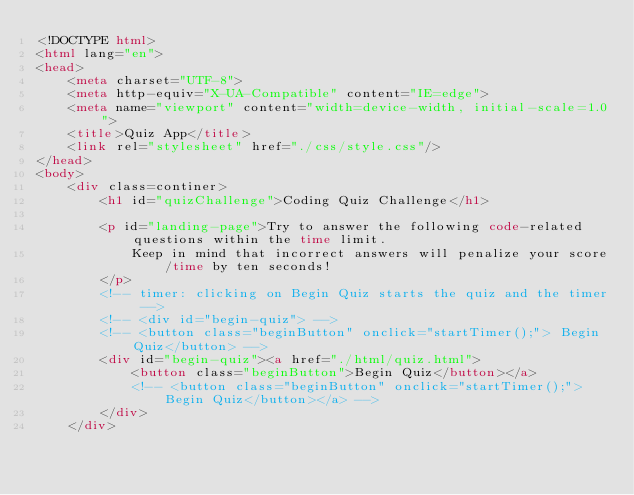Convert code to text. <code><loc_0><loc_0><loc_500><loc_500><_HTML_><!DOCTYPE html>
<html lang="en">
<head>
    <meta charset="UTF-8">
    <meta http-equiv="X-UA-Compatible" content="IE=edge">
    <meta name="viewport" content="width=device-width, initial-scale=1.0">
    <title>Quiz App</title>
    <link rel="stylesheet" href="./css/style.css"/>
</head>
<body>
    <div class=continer>
        <h1 id="quizChallenge">Coding Quiz Challenge</h1>
        
        <p id="landing-page">Try to answer the following code-related questions within the time limit.
            Keep in mind that incorrect answers will penalize your score/time by ten seconds!
        </p>
        <!-- timer: clicking on Begin Quiz starts the quiz and the timer -->
        <!-- <div id="begin-quiz"> -->
        <!-- <button class="beginButton" onclick="startTimer();"> Begin Quiz</button> -->
        <div id="begin-quiz"><a href="./html/quiz.html">
            <button class="beginButton">Begin Quiz</button></a>
            <!-- <button class="beginButton" onclick="startTimer();">Begin Quiz</button></a> -->
        </div>
    </div></code> 